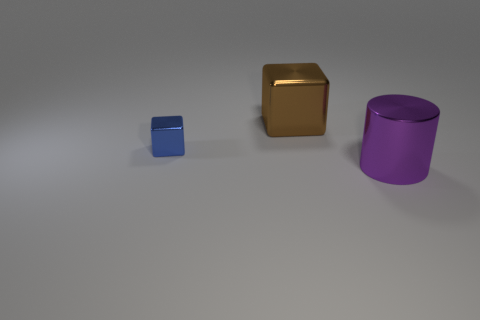Add 1 big red shiny objects. How many objects exist? 4 Subtract all blocks. How many objects are left? 1 Subtract 0 cyan cylinders. How many objects are left? 3 Subtract all red rubber things. Subtract all large brown shiny objects. How many objects are left? 2 Add 3 brown metallic blocks. How many brown metallic blocks are left? 4 Add 3 small blue objects. How many small blue objects exist? 4 